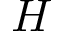<formula> <loc_0><loc_0><loc_500><loc_500>H</formula> 